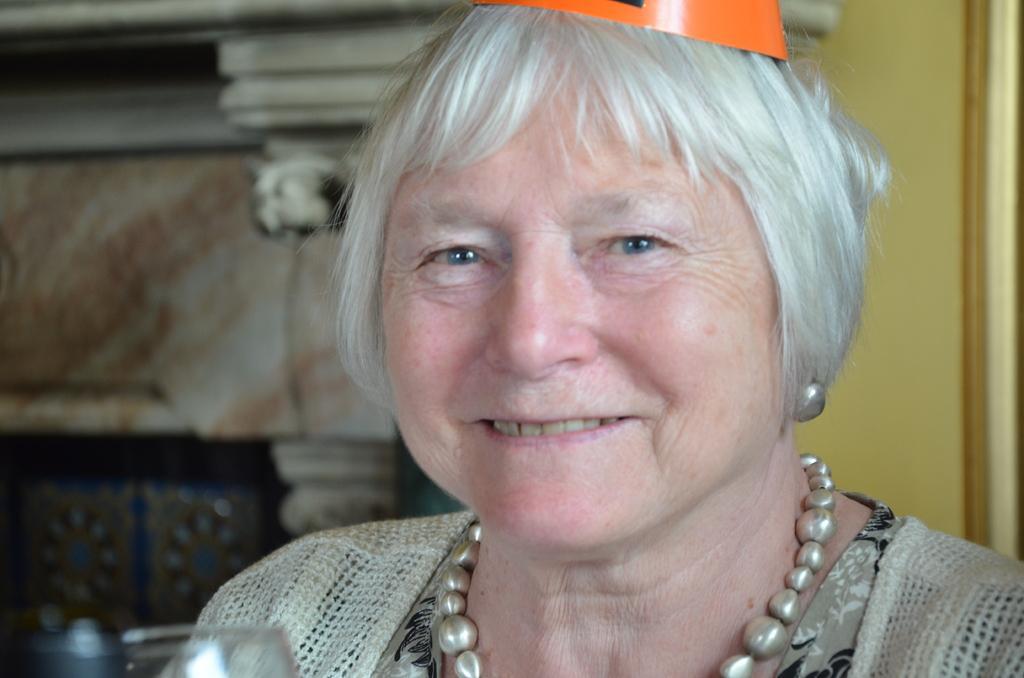How would you summarize this image in a sentence or two? This picture shows a woman wore cap on his head. We see smile on her face and she wore a ornament. 